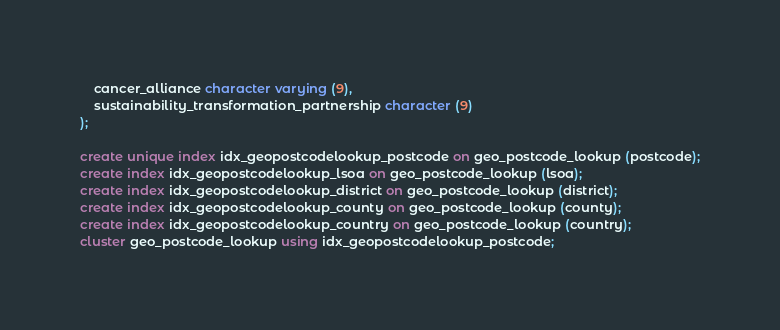Convert code to text. <code><loc_0><loc_0><loc_500><loc_500><_SQL_>    cancer_alliance character varying (9),
    sustainability_transformation_partnership character (9)
);

create unique index idx_geopostcodelookup_postcode on geo_postcode_lookup (postcode);
create index idx_geopostcodelookup_lsoa on geo_postcode_lookup (lsoa);
create index idx_geopostcodelookup_district on geo_postcode_lookup (district);
create index idx_geopostcodelookup_county on geo_postcode_lookup (county);
create index idx_geopostcodelookup_country on geo_postcode_lookup (country);
cluster geo_postcode_lookup using idx_geopostcodelookup_postcode;
</code> 